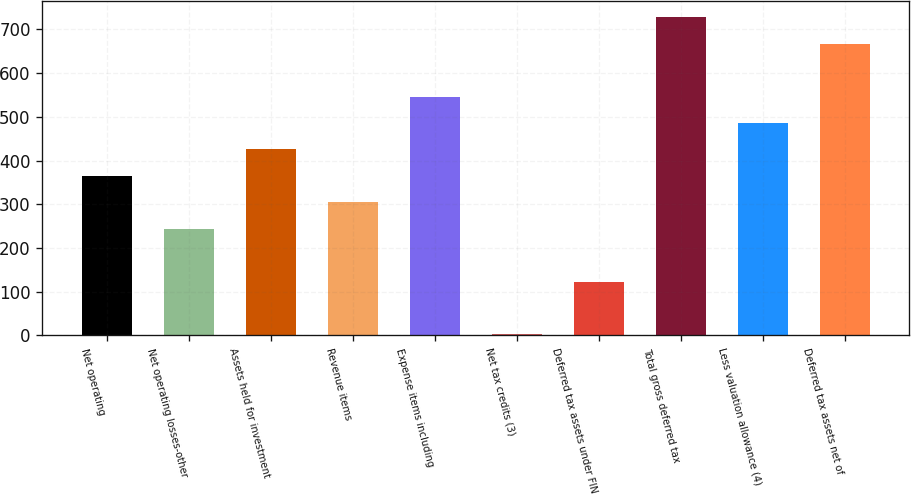<chart> <loc_0><loc_0><loc_500><loc_500><bar_chart><fcel>Net operating<fcel>Net operating losses-other<fcel>Assets held for investment<fcel>Revenue items<fcel>Expense items including<fcel>Net tax credits (3)<fcel>Deferred tax assets under FIN<fcel>Total gross deferred tax<fcel>Less valuation allowance (4)<fcel>Deferred tax assets net of<nl><fcel>365<fcel>244<fcel>425.5<fcel>304.5<fcel>546.5<fcel>2<fcel>123<fcel>728<fcel>486<fcel>667.5<nl></chart> 